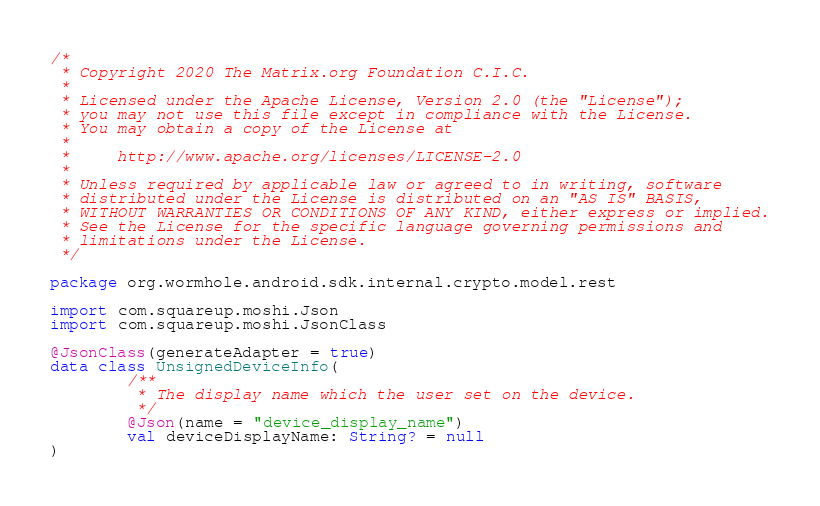Convert code to text. <code><loc_0><loc_0><loc_500><loc_500><_Kotlin_>/*
 * Copyright 2020 The Matrix.org Foundation C.I.C.
 *
 * Licensed under the Apache License, Version 2.0 (the "License");
 * you may not use this file except in compliance with the License.
 * You may obtain a copy of the License at
 *
 *     http://www.apache.org/licenses/LICENSE-2.0
 *
 * Unless required by applicable law or agreed to in writing, software
 * distributed under the License is distributed on an "AS IS" BASIS,
 * WITHOUT WARRANTIES OR CONDITIONS OF ANY KIND, either express or implied.
 * See the License for the specific language governing permissions and
 * limitations under the License.
 */

package org.wormhole.android.sdk.internal.crypto.model.rest

import com.squareup.moshi.Json
import com.squareup.moshi.JsonClass

@JsonClass(generateAdapter = true)
data class UnsignedDeviceInfo(
        /**
         * The display name which the user set on the device.
         */
        @Json(name = "device_display_name")
        val deviceDisplayName: String? = null
)
</code> 